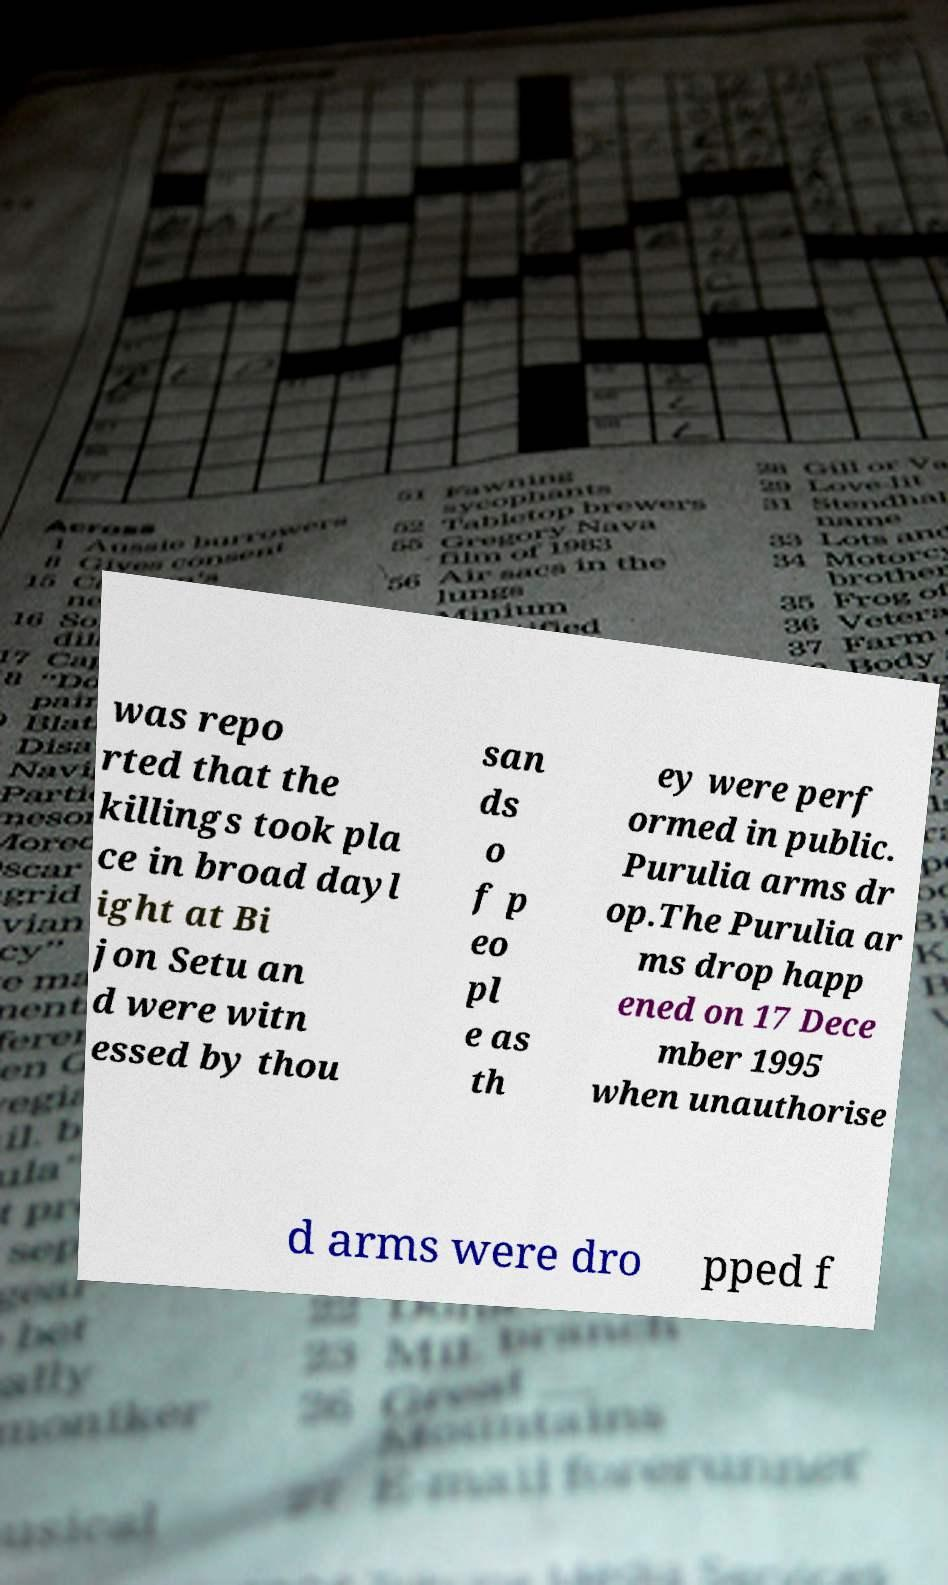I need the written content from this picture converted into text. Can you do that? was repo rted that the killings took pla ce in broad dayl ight at Bi jon Setu an d were witn essed by thou san ds o f p eo pl e as th ey were perf ormed in public. Purulia arms dr op.The Purulia ar ms drop happ ened on 17 Dece mber 1995 when unauthorise d arms were dro pped f 